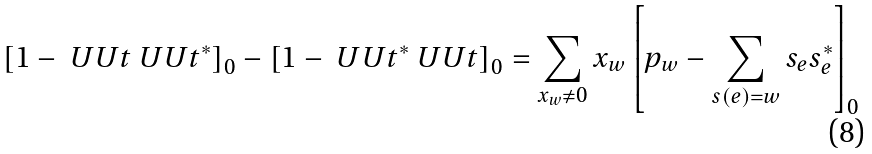Convert formula to latex. <formula><loc_0><loc_0><loc_500><loc_500>\left [ 1 - \ U U t \ U U t ^ { * } \right ] _ { 0 } - \left [ 1 - \ U U t ^ { * } \ U U t \right ] _ { 0 } = \sum _ { x _ { w } \not = 0 } x _ { w } \left [ p _ { w } - \sum _ { s ( e ) = w } s _ { e } s _ { e } ^ { * } \right ] _ { 0 }</formula> 